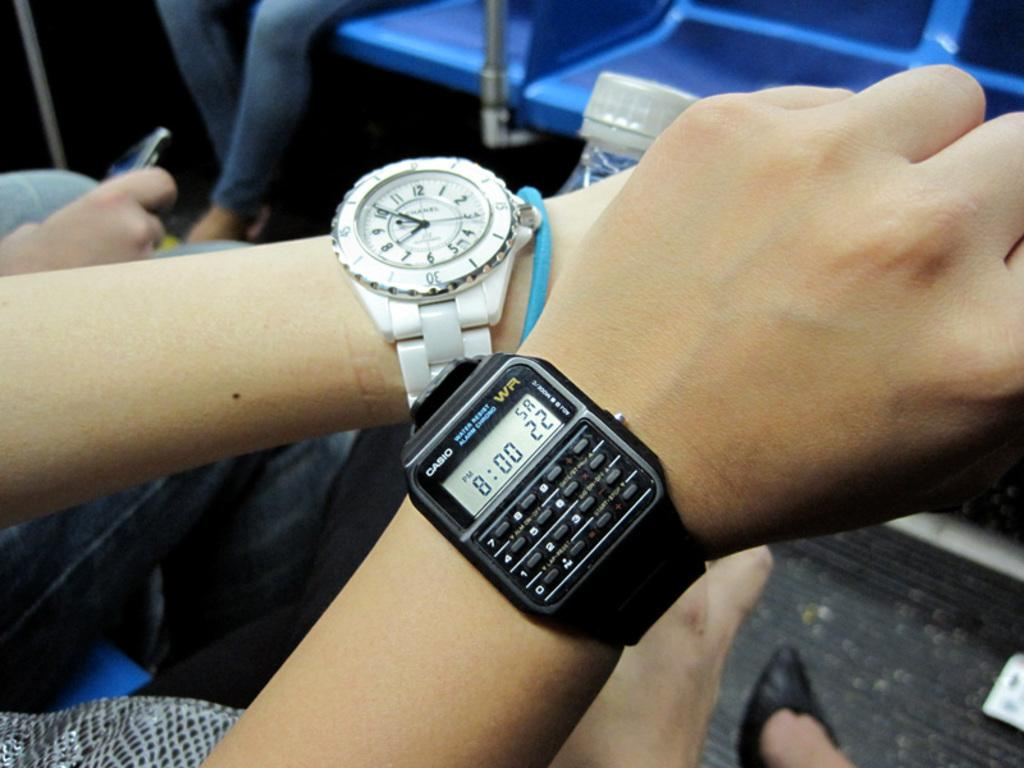Provide a one-sentence caption for the provided image. Person wearing a wrist watch which says the time at 8:00 on it. 